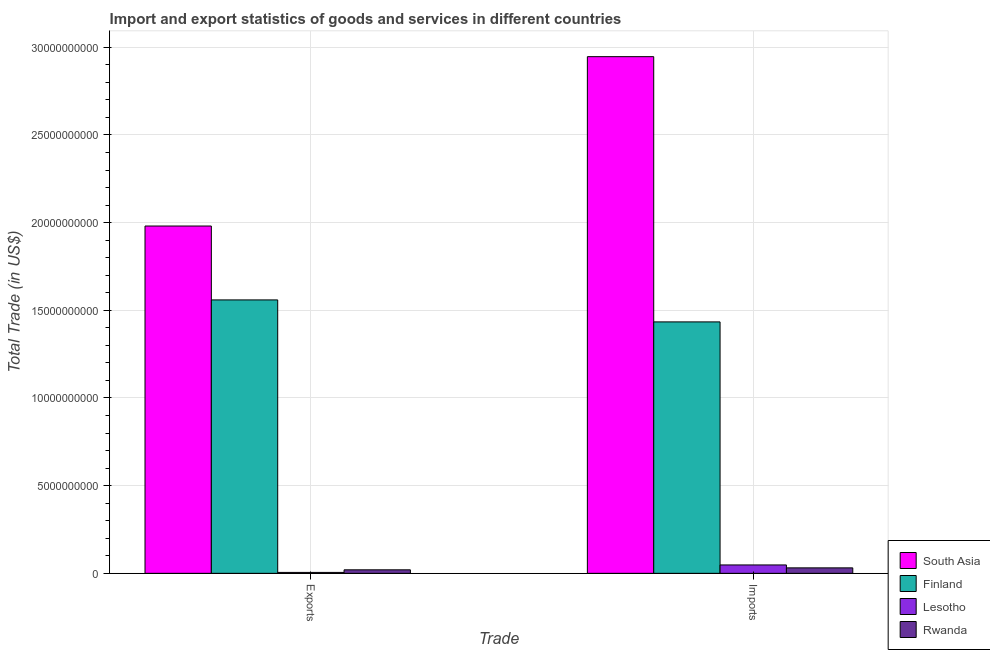How many different coloured bars are there?
Keep it short and to the point. 4. How many groups of bars are there?
Your answer should be very brief. 2. Are the number of bars per tick equal to the number of legend labels?
Your answer should be very brief. Yes. How many bars are there on the 2nd tick from the left?
Your answer should be very brief. 4. How many bars are there on the 2nd tick from the right?
Make the answer very short. 4. What is the label of the 2nd group of bars from the left?
Offer a terse response. Imports. What is the imports of goods and services in Finland?
Offer a terse response. 1.43e+1. Across all countries, what is the maximum imports of goods and services?
Provide a succinct answer. 2.95e+1. Across all countries, what is the minimum imports of goods and services?
Your answer should be very brief. 3.12e+08. In which country was the imports of goods and services maximum?
Offer a very short reply. South Asia. In which country was the export of goods and services minimum?
Ensure brevity in your answer.  Lesotho. What is the total imports of goods and services in the graph?
Keep it short and to the point. 4.46e+1. What is the difference between the imports of goods and services in Finland and that in Rwanda?
Provide a succinct answer. 1.40e+1. What is the difference between the export of goods and services in Rwanda and the imports of goods and services in Lesotho?
Provide a succinct answer. -2.78e+08. What is the average imports of goods and services per country?
Keep it short and to the point. 1.11e+1. What is the difference between the imports of goods and services and export of goods and services in Rwanda?
Make the answer very short. 1.12e+08. In how many countries, is the export of goods and services greater than 16000000000 US$?
Your answer should be compact. 1. What is the ratio of the export of goods and services in Finland to that in Rwanda?
Ensure brevity in your answer.  77.77. Is the imports of goods and services in Rwanda less than that in Lesotho?
Your answer should be very brief. Yes. What does the 1st bar from the right in Imports represents?
Your answer should be very brief. Rwanda. How many countries are there in the graph?
Make the answer very short. 4. What is the difference between two consecutive major ticks on the Y-axis?
Make the answer very short. 5.00e+09. Are the values on the major ticks of Y-axis written in scientific E-notation?
Make the answer very short. No. Does the graph contain any zero values?
Provide a short and direct response. No. Does the graph contain grids?
Offer a very short reply. Yes. How many legend labels are there?
Offer a terse response. 4. What is the title of the graph?
Offer a very short reply. Import and export statistics of goods and services in different countries. Does "Guatemala" appear as one of the legend labels in the graph?
Your response must be concise. No. What is the label or title of the X-axis?
Provide a short and direct response. Trade. What is the label or title of the Y-axis?
Make the answer very short. Total Trade (in US$). What is the Total Trade (in US$) of South Asia in Exports?
Keep it short and to the point. 1.98e+1. What is the Total Trade (in US$) in Finland in Exports?
Ensure brevity in your answer.  1.56e+1. What is the Total Trade (in US$) of Lesotho in Exports?
Your answer should be very brief. 5.27e+07. What is the Total Trade (in US$) in Rwanda in Exports?
Keep it short and to the point. 2.01e+08. What is the Total Trade (in US$) in South Asia in Imports?
Your answer should be compact. 2.95e+1. What is the Total Trade (in US$) of Finland in Imports?
Provide a short and direct response. 1.43e+1. What is the Total Trade (in US$) of Lesotho in Imports?
Provide a short and direct response. 4.78e+08. What is the Total Trade (in US$) of Rwanda in Imports?
Offer a terse response. 3.12e+08. Across all Trade, what is the maximum Total Trade (in US$) in South Asia?
Give a very brief answer. 2.95e+1. Across all Trade, what is the maximum Total Trade (in US$) of Finland?
Provide a short and direct response. 1.56e+1. Across all Trade, what is the maximum Total Trade (in US$) of Lesotho?
Ensure brevity in your answer.  4.78e+08. Across all Trade, what is the maximum Total Trade (in US$) in Rwanda?
Your response must be concise. 3.12e+08. Across all Trade, what is the minimum Total Trade (in US$) of South Asia?
Ensure brevity in your answer.  1.98e+1. Across all Trade, what is the minimum Total Trade (in US$) in Finland?
Offer a terse response. 1.43e+1. Across all Trade, what is the minimum Total Trade (in US$) of Lesotho?
Your answer should be compact. 5.27e+07. Across all Trade, what is the minimum Total Trade (in US$) of Rwanda?
Keep it short and to the point. 2.01e+08. What is the total Total Trade (in US$) in South Asia in the graph?
Provide a succinct answer. 4.93e+1. What is the total Total Trade (in US$) of Finland in the graph?
Make the answer very short. 2.99e+1. What is the total Total Trade (in US$) of Lesotho in the graph?
Your answer should be compact. 5.31e+08. What is the total Total Trade (in US$) of Rwanda in the graph?
Your answer should be very brief. 5.13e+08. What is the difference between the Total Trade (in US$) in South Asia in Exports and that in Imports?
Offer a terse response. -9.66e+09. What is the difference between the Total Trade (in US$) in Finland in Exports and that in Imports?
Give a very brief answer. 1.25e+09. What is the difference between the Total Trade (in US$) in Lesotho in Exports and that in Imports?
Make the answer very short. -4.26e+08. What is the difference between the Total Trade (in US$) in Rwanda in Exports and that in Imports?
Offer a terse response. -1.12e+08. What is the difference between the Total Trade (in US$) of South Asia in Exports and the Total Trade (in US$) of Finland in Imports?
Keep it short and to the point. 5.47e+09. What is the difference between the Total Trade (in US$) of South Asia in Exports and the Total Trade (in US$) of Lesotho in Imports?
Offer a terse response. 1.93e+1. What is the difference between the Total Trade (in US$) in South Asia in Exports and the Total Trade (in US$) in Rwanda in Imports?
Provide a short and direct response. 1.95e+1. What is the difference between the Total Trade (in US$) in Finland in Exports and the Total Trade (in US$) in Lesotho in Imports?
Keep it short and to the point. 1.51e+1. What is the difference between the Total Trade (in US$) of Finland in Exports and the Total Trade (in US$) of Rwanda in Imports?
Provide a short and direct response. 1.53e+1. What is the difference between the Total Trade (in US$) of Lesotho in Exports and the Total Trade (in US$) of Rwanda in Imports?
Your answer should be very brief. -2.59e+08. What is the average Total Trade (in US$) in South Asia per Trade?
Give a very brief answer. 2.46e+1. What is the average Total Trade (in US$) of Finland per Trade?
Keep it short and to the point. 1.50e+1. What is the average Total Trade (in US$) in Lesotho per Trade?
Offer a very short reply. 2.66e+08. What is the average Total Trade (in US$) of Rwanda per Trade?
Your answer should be compact. 2.56e+08. What is the difference between the Total Trade (in US$) of South Asia and Total Trade (in US$) of Finland in Exports?
Your answer should be very brief. 4.21e+09. What is the difference between the Total Trade (in US$) in South Asia and Total Trade (in US$) in Lesotho in Exports?
Your answer should be very brief. 1.98e+1. What is the difference between the Total Trade (in US$) of South Asia and Total Trade (in US$) of Rwanda in Exports?
Give a very brief answer. 1.96e+1. What is the difference between the Total Trade (in US$) in Finland and Total Trade (in US$) in Lesotho in Exports?
Offer a terse response. 1.55e+1. What is the difference between the Total Trade (in US$) in Finland and Total Trade (in US$) in Rwanda in Exports?
Your response must be concise. 1.54e+1. What is the difference between the Total Trade (in US$) of Lesotho and Total Trade (in US$) of Rwanda in Exports?
Provide a short and direct response. -1.48e+08. What is the difference between the Total Trade (in US$) of South Asia and Total Trade (in US$) of Finland in Imports?
Ensure brevity in your answer.  1.51e+1. What is the difference between the Total Trade (in US$) in South Asia and Total Trade (in US$) in Lesotho in Imports?
Offer a very short reply. 2.90e+1. What is the difference between the Total Trade (in US$) of South Asia and Total Trade (in US$) of Rwanda in Imports?
Offer a very short reply. 2.92e+1. What is the difference between the Total Trade (in US$) in Finland and Total Trade (in US$) in Lesotho in Imports?
Provide a succinct answer. 1.39e+1. What is the difference between the Total Trade (in US$) in Finland and Total Trade (in US$) in Rwanda in Imports?
Your response must be concise. 1.40e+1. What is the difference between the Total Trade (in US$) of Lesotho and Total Trade (in US$) of Rwanda in Imports?
Provide a succinct answer. 1.66e+08. What is the ratio of the Total Trade (in US$) of South Asia in Exports to that in Imports?
Your response must be concise. 0.67. What is the ratio of the Total Trade (in US$) in Finland in Exports to that in Imports?
Your answer should be very brief. 1.09. What is the ratio of the Total Trade (in US$) of Lesotho in Exports to that in Imports?
Your response must be concise. 0.11. What is the ratio of the Total Trade (in US$) in Rwanda in Exports to that in Imports?
Your response must be concise. 0.64. What is the difference between the highest and the second highest Total Trade (in US$) of South Asia?
Offer a very short reply. 9.66e+09. What is the difference between the highest and the second highest Total Trade (in US$) in Finland?
Make the answer very short. 1.25e+09. What is the difference between the highest and the second highest Total Trade (in US$) of Lesotho?
Ensure brevity in your answer.  4.26e+08. What is the difference between the highest and the second highest Total Trade (in US$) of Rwanda?
Offer a terse response. 1.12e+08. What is the difference between the highest and the lowest Total Trade (in US$) in South Asia?
Your answer should be very brief. 9.66e+09. What is the difference between the highest and the lowest Total Trade (in US$) of Finland?
Ensure brevity in your answer.  1.25e+09. What is the difference between the highest and the lowest Total Trade (in US$) in Lesotho?
Give a very brief answer. 4.26e+08. What is the difference between the highest and the lowest Total Trade (in US$) in Rwanda?
Your answer should be very brief. 1.12e+08. 